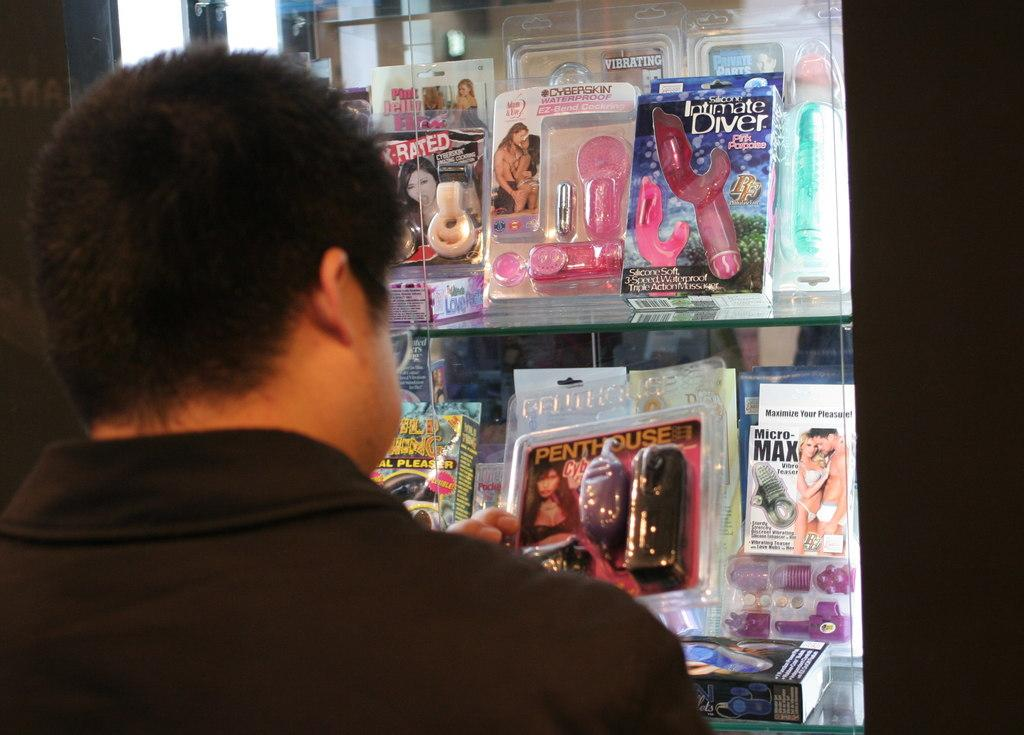Who is present in the image? There is a person in the image. What is the person doing in the image? The person is looking at some packets. What can be seen in the background of the image? The background of the image is black. What is the person's opinion on the quartz in the image? There is no quartz present in the image, so it is not possible to determine the person's opinion on it. 